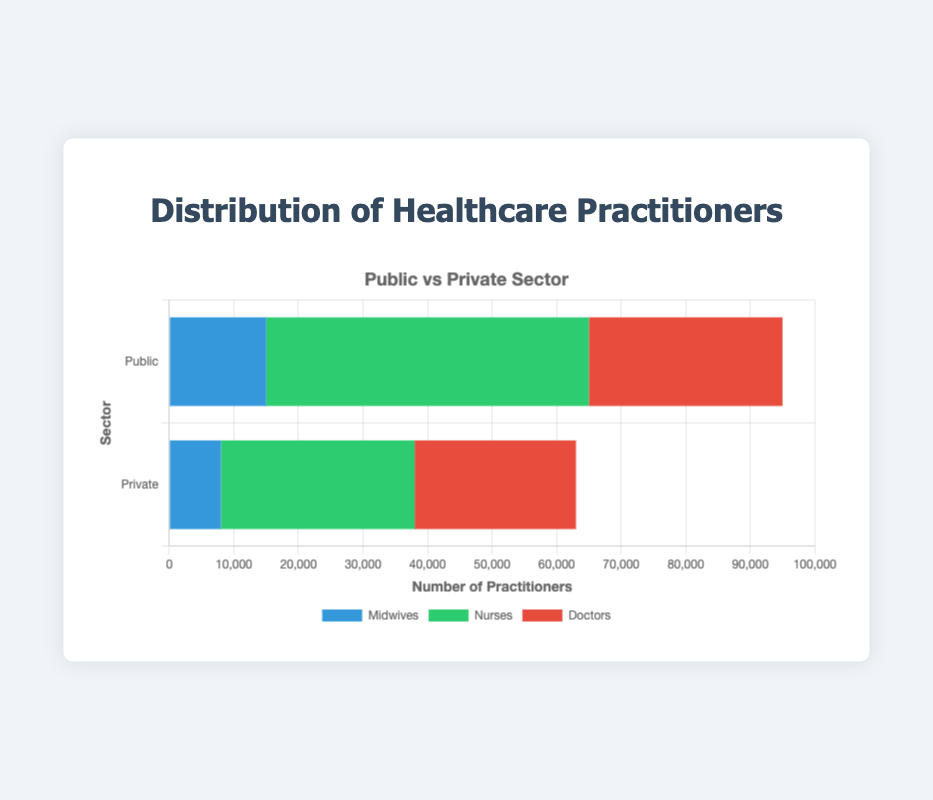How many more midwives are there in the public sector compared to the private sector? To find the difference between midwives in the public and private sectors, subtract the number in the private sector from the number in the public sector. Public: 15,000; Private: 8,000. 15,000 - 8,000 = 7,000
Answer: 7,000 Which sector employs more doctors? Compare the number of doctors in the public and private sectors. Public sector: 30,000; Private sector: 25,000. The public sector employs more doctors.
Answer: Public What is the total number of healthcare practitioners (midwives, nurses, and doctors) in the public sector? Add the number of midwives, nurses, and doctors in the public sector. 15,000 (midwives) + 50,000 (nurses) + 30,000 (doctors) = 95,000
Answer: 95,000 What is the ratio of nurses to midwives in the private sector? Divide the number of nurses by the number of midwives in the private sector. Nurses: 30,000; Midwives: 8,000. 30,000 / 8,000 = 3.75
Answer: 3.75 By how much does the number of nurses in the public sector exceed the number of nurses in the private sector? Subtract the number of nurses in the private sector from those in the public sector. Public: 50,000; Private: 30,000. 50,000 - 30,000 = 20,000
Answer: 20,000 Which role has the highest number of practitioners in the public sector? Compare the numbers for midwives, nurses, and doctors in the public sector. Nurses: 50,000; Midwives: 15,000; Doctors: 30,000. The highest is nurses with 50,000
Answer: Nurses What is the combined total of midwives in both sectors? Add the number of midwives in the public and private sectors. Public: 15,000; Private: 8,000. 15,000 + 8,000 = 23,000
Answer: 23,000 In the private sector, how does the number of doctors compare to the number of nurses? Compare the number of doctors and nurses in the private sector. Doctors: 25,000; Nurses: 30,000. There are more nurses than doctors.
Answer: More nurses What percentage of healthcare practitioners in the public sector are doctors? Divide the number of doctors by the total number of healthcare practitioners in the public sector and multiply by 100. Doctors: 30,000; Total in public: 95,000. (30,000 / 95,000) * 100 ≈ 31.58%
Answer: 31.58% Is the combined number of healthcare practitioners in the private sector greater than that in the public sector? Calculate and compare the totals for each sector. Public sector: 95,000; Private sector: 8,000 (midwives) + 30,000 (nurses) + 25,000 (doctors) = 63,000. 63,000 < 95,000, so no.
Answer: No 